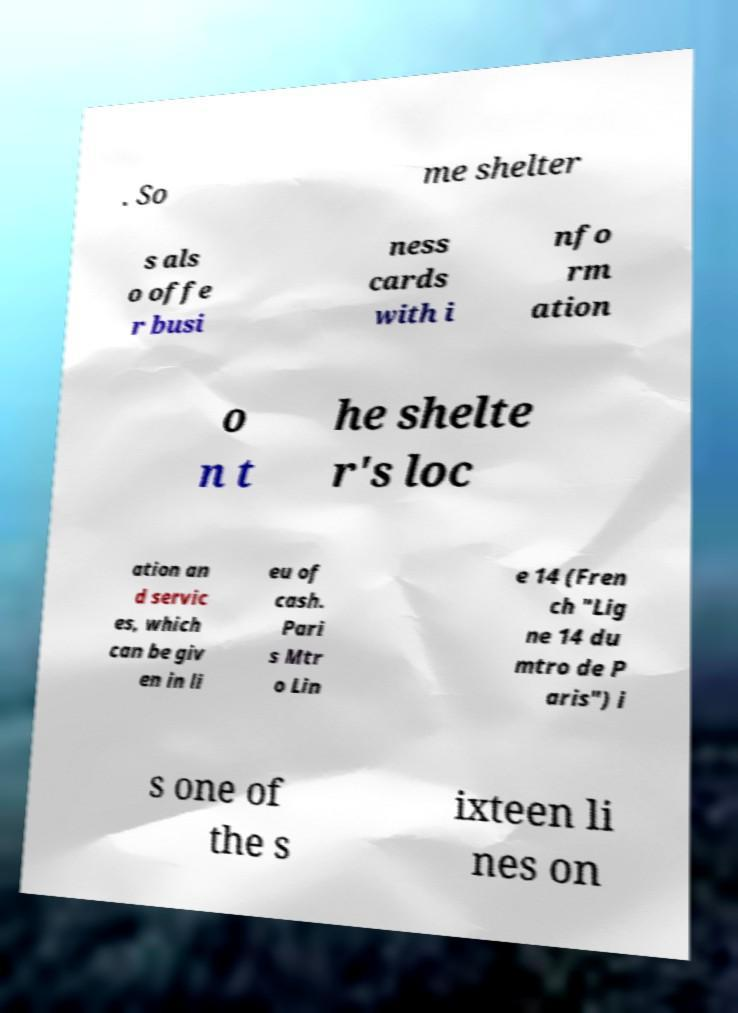Can you accurately transcribe the text from the provided image for me? . So me shelter s als o offe r busi ness cards with i nfo rm ation o n t he shelte r's loc ation an d servic es, which can be giv en in li eu of cash. Pari s Mtr o Lin e 14 (Fren ch "Lig ne 14 du mtro de P aris") i s one of the s ixteen li nes on 